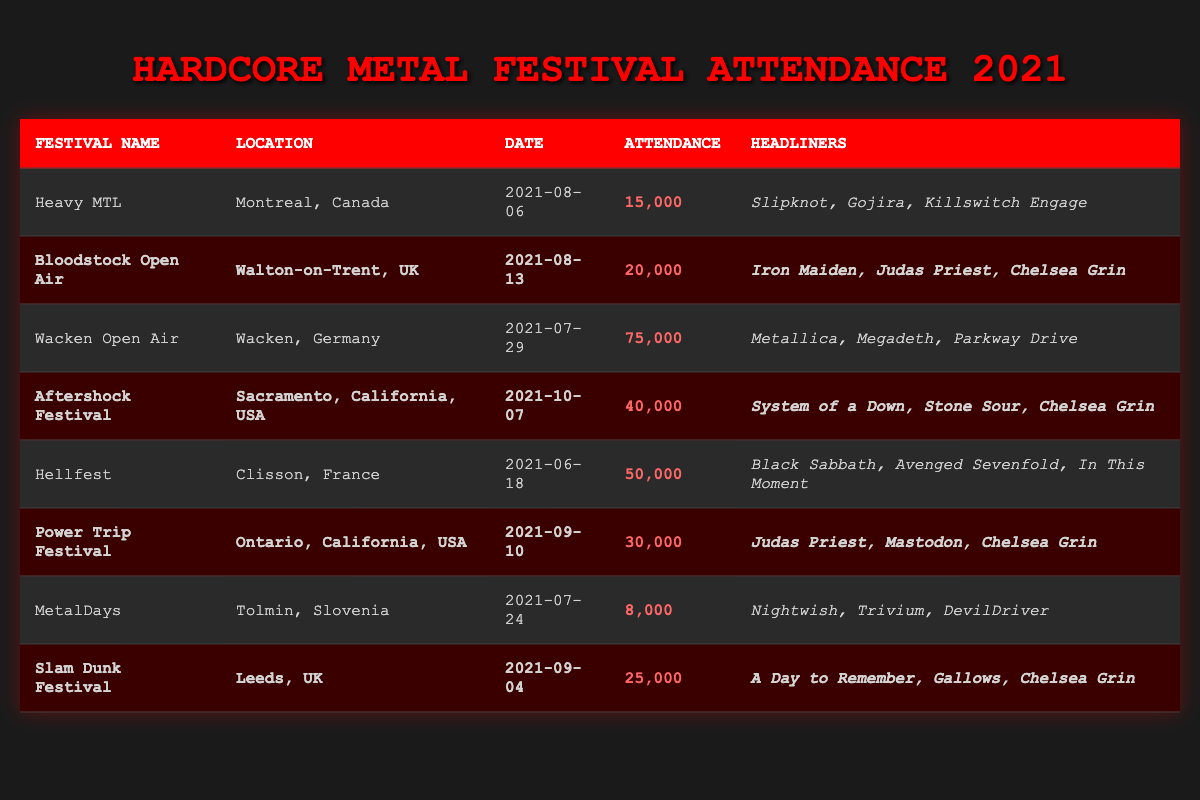What was the highest attendance at a hardcore metal festival in 2021? The festival with the highest attendance is Wacken Open Air, which had an attendance of 75,000. This value can be found by looking through the attendance column and identifying the maximum number.
Answer: 75,000 Which festival had Chelsea Grin as a headliner and the date closest to the end of 2021? The Aftershock Festival took place on October 7, 2021, and Chelsea Grin was one of the headliners. To find this, look for festivals with Chelsea Grin in the headliners column and then compare their dates.
Answer: Aftershock Festival How many festivals had an attendance of over 30,000? There are four festivals with attendance over 30,000: Wacken Open Air (75,000), Hellfest (50,000), Aftershock Festival (40,000), and Power Trip Festival (30,000). By counting these festivals from the table, we get the total.
Answer: 4 Is it true that all festivals listed in the table took place in Europe? This statement is false. The Aftershock Festival and Power Trip Festival took place in the USA, while the others are in Europe. By checking the location column, we can see there are events in North America.
Answer: No What is the total attendance of festivals that took place in the USA? To find the total attendance of festivals in the USA, we look at Aftershock Festival (40,000), Power Trip Festival (30,000), and Heavy MTL (which is in Canada and not included). So the total is 40,000 + 30,000 = 70,000.
Answer: 70,000 Which festival in the UK had the least attendance? MetalDays is not in the UK, while Slam Dunk Festival and Bloodstock Open Air are. Slam Dunk Festival had the least attendance with 25,000. We determine this by comparing attendance figures of UK festivals.
Answer: Slam Dunk Festival How many headliners were listed for Wacken Open Air? Wacken Open Air had three headliners: Metallica, Megadeth, and Parkway Drive. This is straight from the headliners column for that festival.
Answer: 3 What festival in France had an attendance of over 40,000? The festival you're looking for is Hellfest, with an attendance of 50,000, which can be identified by checking the location and attendance columns.
Answer: Hellfest 